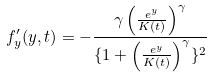<formula> <loc_0><loc_0><loc_500><loc_500>f ^ { \prime } _ { y } ( y , t ) = - \frac { \gamma \left ( \frac { e ^ { y } } { K ( t ) } \right ) ^ { \gamma } } { \{ 1 + \left ( \frac { e ^ { y } } { K ( t ) } \right ) ^ { \gamma } \} ^ { 2 } }</formula> 